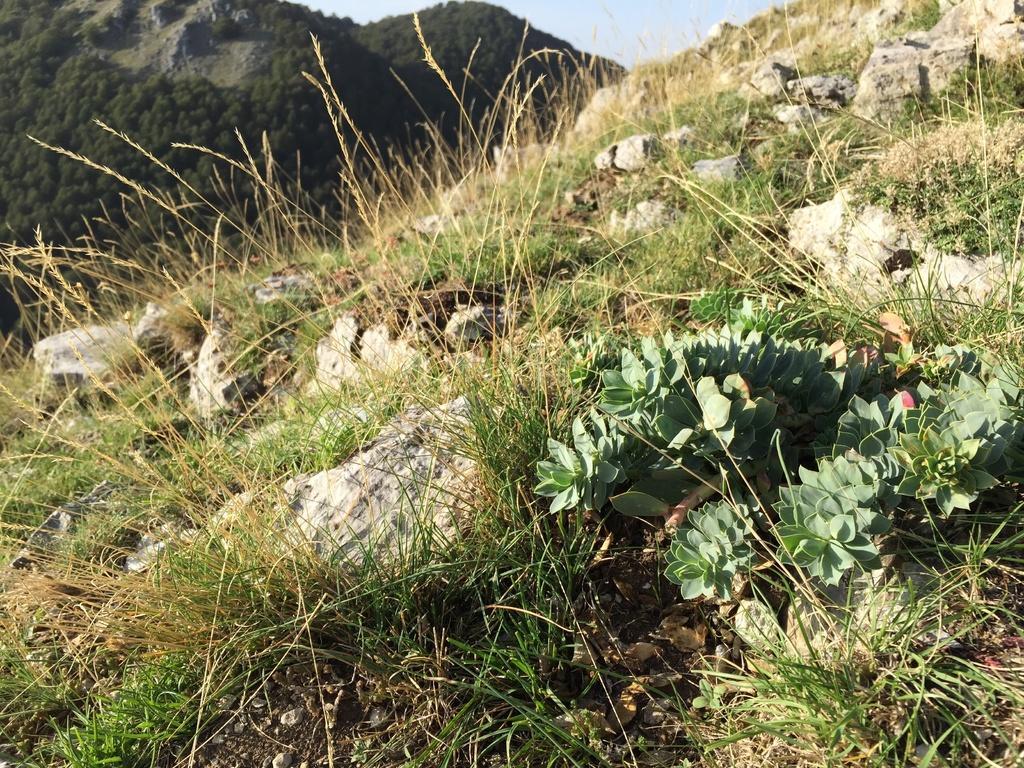How would you summarize this image in a sentence or two? In this image there are mountains covered with trees, stones, grass, plants and the sky. 